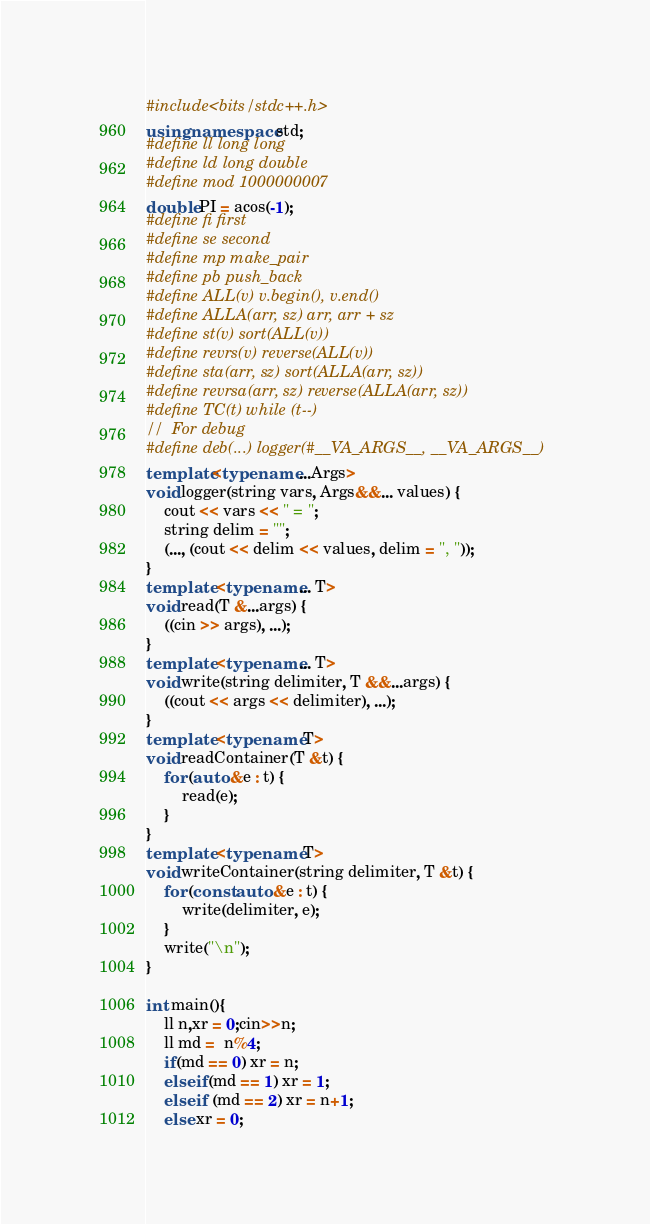Convert code to text. <code><loc_0><loc_0><loc_500><loc_500><_C++_>#include<bits/stdc++.h>
using namespace std;
#define ll long long
#define ld long double
#define mod 1000000007
double PI = acos(-1);
#define fi first
#define se second
#define mp make_pair
#define pb push_back
#define ALL(v) v.begin(), v.end()
#define ALLA(arr, sz) arr, arr + sz
#define st(v) sort(ALL(v))
#define revrs(v) reverse(ALL(v))
#define sta(arr, sz) sort(ALLA(arr, sz))
#define revrsa(arr, sz) reverse(ALLA(arr, sz))
#define TC(t) while (t--)
//  For debug
#define deb(...) logger(#__VA_ARGS__, __VA_ARGS__)
template<typename ...Args>
void logger(string vars, Args&&... values) {
    cout << vars << " = ";
    string delim = "";
    (..., (cout << delim << values, delim = ", "));
}
template <typename... T>
void read(T &...args) {
    ((cin >> args), ...);
}
template <typename... T>
void write(string delimiter, T &&...args) {
    ((cout << args << delimiter), ...);
}
template <typename T>
void readContainer(T &t) {
    for (auto &e : t) {
        read(e);
    }
}
template <typename T>
void writeContainer(string delimiter, T &t) {
    for (const auto &e : t) {
        write(delimiter, e);
    }
    write("\n");
}

int main(){
    ll n,xr = 0;cin>>n;
    ll md =  n%4;
    if(md == 0) xr = n;
    else if(md == 1) xr = 1;
    else if (md == 2) xr = n+1;
    else xr = 0;</code> 